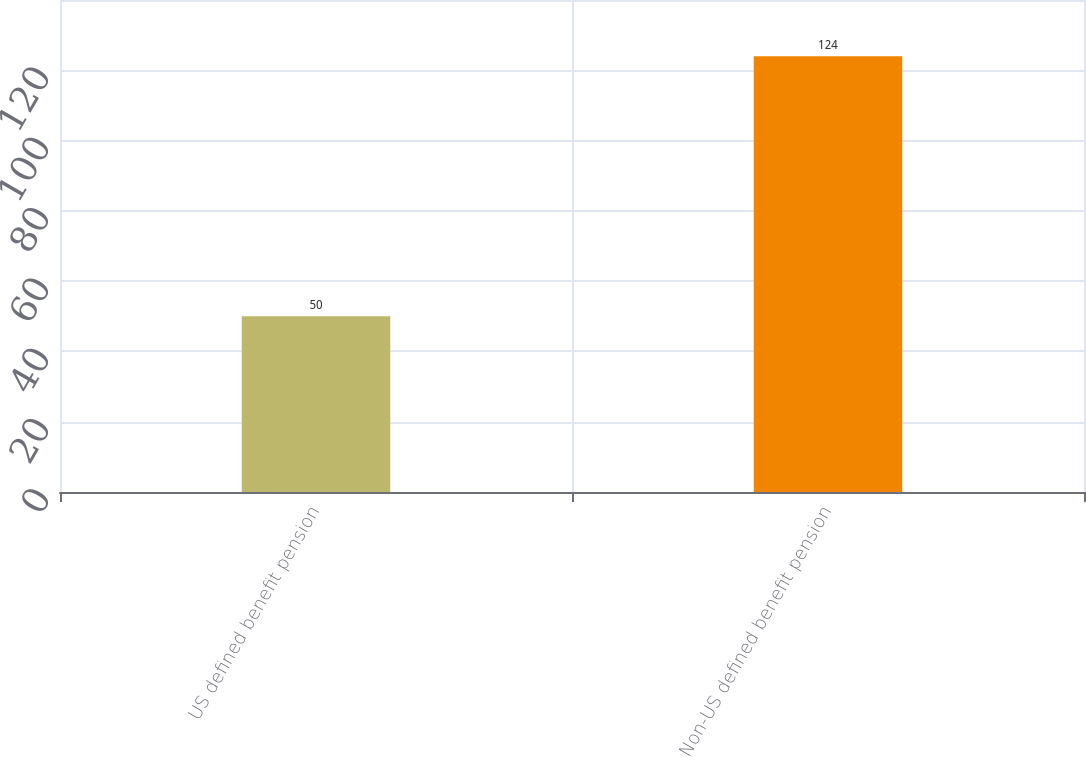Convert chart to OTSL. <chart><loc_0><loc_0><loc_500><loc_500><bar_chart><fcel>US defined benefit pension<fcel>Non-US defined benefit pension<nl><fcel>50<fcel>124<nl></chart> 